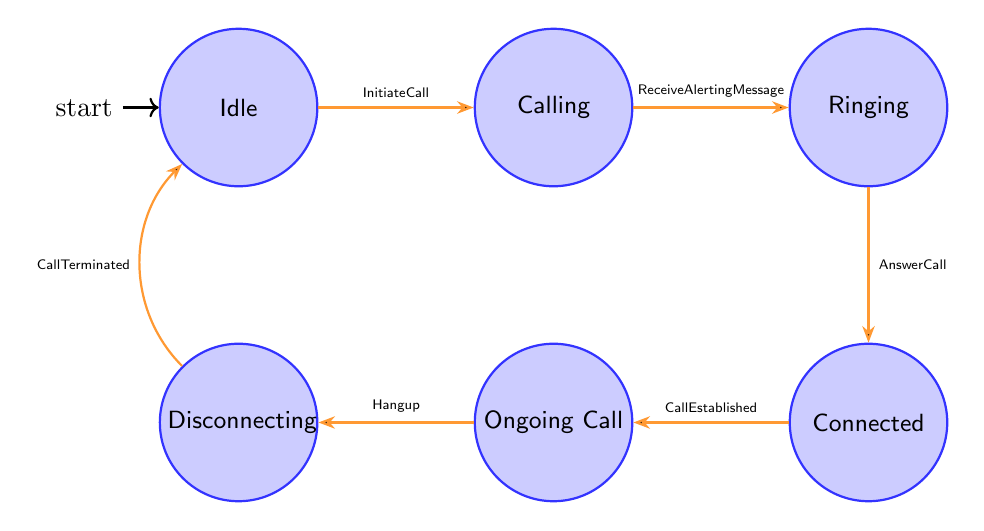What is the initial state of the call setup process? According to the diagram, the initial state is labeled as "Idle," which indicates that the mobile device is powered on but not engaged in any active call.
Answer: Idle How many states are present in the diagram? The diagram displays a total of six states: Idle, Calling, Ringing, Connected, Ongoing Call, and Disconnecting. Therefore, when counted, there are six distinct states.
Answer: 6 Which state follows "Calling"? In the state transition sequence outlined in the diagram, the state that directly follows "Calling" is "Ringing," as indicated by the transition labeled "ReceiveAlertingMessage."
Answer: Ringing What action occurs when transitioning from "Ringing" to "Connected"? The diagram states that the action occurring during this transition is "Destination device accepts the call," known as "AnswerCall." This indicates that once the call is answered, the state changes.
Answer: Destination device accepts the call What is the action taken during the transition from "Ongoing Call" to "Disconnecting"? The action specified for the transition from "Ongoing Call" to "Disconnecting" is "Initiate call termination," which signifies that either party is starting the process to end the call.
Answer: Initiate call termination Which states are directly connected to "Disconnecting"? The "Disconnecting" state is directly connected to two states: "Ongoing Call" (leading into it) and "Idle" (leading out of it). The transition to "Idle" happens after "CallTerminated."
Answer: Ongoing Call, Idle What triggers the transition from "Connected" to "Ongoing Call"? The transition from "Connected" to "Ongoing Call" is triggered by the "CallEstablished" event. This indicates that all necessary communication channels are set up for the call to proceed.
Answer: CallEstablished What is the final state of the call setup process? The final state, once the "Disconnecting" phase is complete and all resources are released, is "Idle," indicating that the system has returned to its initial state waiting for a new call setup.
Answer: Idle 